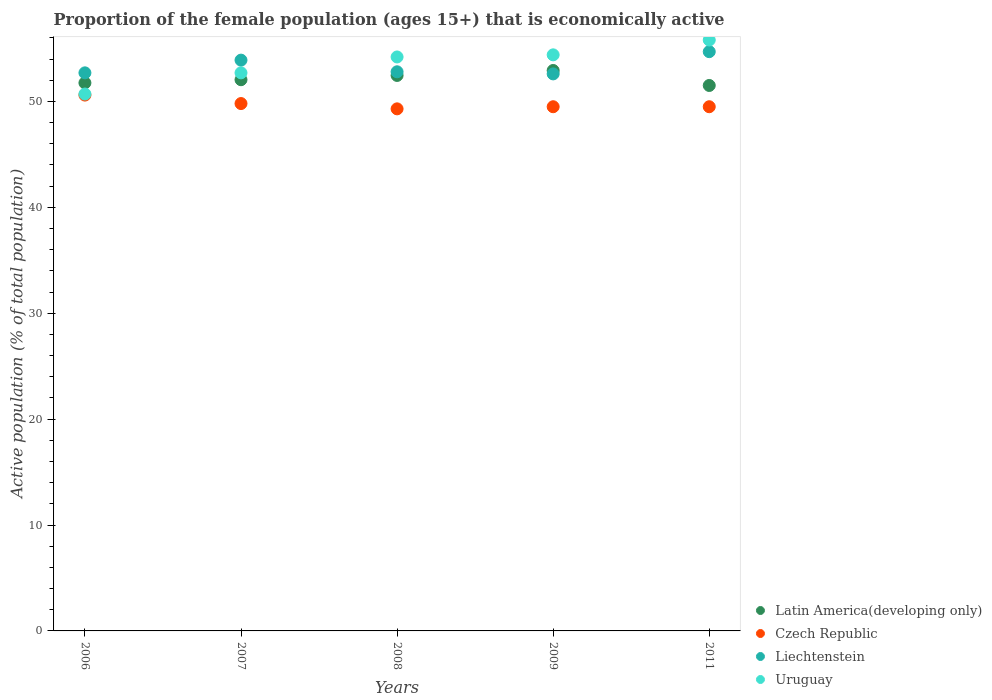How many different coloured dotlines are there?
Offer a very short reply. 4. What is the proportion of the female population that is economically active in Uruguay in 2011?
Your answer should be very brief. 55.8. Across all years, what is the maximum proportion of the female population that is economically active in Czech Republic?
Your response must be concise. 50.6. Across all years, what is the minimum proportion of the female population that is economically active in Czech Republic?
Offer a very short reply. 49.3. In which year was the proportion of the female population that is economically active in Czech Republic minimum?
Your answer should be compact. 2008. What is the total proportion of the female population that is economically active in Uruguay in the graph?
Ensure brevity in your answer.  267.8. What is the difference between the proportion of the female population that is economically active in Czech Republic in 2006 and that in 2011?
Your answer should be very brief. 1.1. What is the difference between the proportion of the female population that is economically active in Uruguay in 2006 and the proportion of the female population that is economically active in Czech Republic in 2011?
Give a very brief answer. 1.2. What is the average proportion of the female population that is economically active in Uruguay per year?
Ensure brevity in your answer.  53.56. In the year 2006, what is the difference between the proportion of the female population that is economically active in Uruguay and proportion of the female population that is economically active in Czech Republic?
Your answer should be compact. 0.1. In how many years, is the proportion of the female population that is economically active in Liechtenstein greater than 38 %?
Make the answer very short. 5. What is the ratio of the proportion of the female population that is economically active in Uruguay in 2007 to that in 2009?
Make the answer very short. 0.97. What is the difference between the highest and the second highest proportion of the female population that is economically active in Uruguay?
Your answer should be compact. 1.4. What is the difference between the highest and the lowest proportion of the female population that is economically active in Latin America(developing only)?
Your answer should be very brief. 1.41. Is it the case that in every year, the sum of the proportion of the female population that is economically active in Liechtenstein and proportion of the female population that is economically active in Latin America(developing only)  is greater than the proportion of the female population that is economically active in Czech Republic?
Keep it short and to the point. Yes. Is the proportion of the female population that is economically active in Latin America(developing only) strictly greater than the proportion of the female population that is economically active in Liechtenstein over the years?
Your answer should be compact. No. Is the proportion of the female population that is economically active in Czech Republic strictly less than the proportion of the female population that is economically active in Latin America(developing only) over the years?
Ensure brevity in your answer.  Yes. What is the difference between two consecutive major ticks on the Y-axis?
Give a very brief answer. 10. Are the values on the major ticks of Y-axis written in scientific E-notation?
Offer a terse response. No. Does the graph contain grids?
Give a very brief answer. No. How many legend labels are there?
Offer a very short reply. 4. How are the legend labels stacked?
Keep it short and to the point. Vertical. What is the title of the graph?
Give a very brief answer. Proportion of the female population (ages 15+) that is economically active. Does "Sweden" appear as one of the legend labels in the graph?
Your answer should be very brief. No. What is the label or title of the Y-axis?
Give a very brief answer. Active population (% of total population). What is the Active population (% of total population) in Latin America(developing only) in 2006?
Offer a terse response. 51.75. What is the Active population (% of total population) of Czech Republic in 2006?
Your answer should be very brief. 50.6. What is the Active population (% of total population) of Liechtenstein in 2006?
Your answer should be very brief. 52.7. What is the Active population (% of total population) in Uruguay in 2006?
Offer a very short reply. 50.7. What is the Active population (% of total population) in Latin America(developing only) in 2007?
Offer a terse response. 52.05. What is the Active population (% of total population) of Czech Republic in 2007?
Provide a short and direct response. 49.8. What is the Active population (% of total population) in Liechtenstein in 2007?
Your answer should be compact. 53.9. What is the Active population (% of total population) of Uruguay in 2007?
Provide a short and direct response. 52.7. What is the Active population (% of total population) of Latin America(developing only) in 2008?
Give a very brief answer. 52.45. What is the Active population (% of total population) of Czech Republic in 2008?
Keep it short and to the point. 49.3. What is the Active population (% of total population) in Liechtenstein in 2008?
Make the answer very short. 52.8. What is the Active population (% of total population) in Uruguay in 2008?
Provide a short and direct response. 54.2. What is the Active population (% of total population) in Latin America(developing only) in 2009?
Offer a very short reply. 52.92. What is the Active population (% of total population) in Czech Republic in 2009?
Your answer should be compact. 49.5. What is the Active population (% of total population) of Liechtenstein in 2009?
Provide a succinct answer. 52.6. What is the Active population (% of total population) in Uruguay in 2009?
Keep it short and to the point. 54.4. What is the Active population (% of total population) in Latin America(developing only) in 2011?
Ensure brevity in your answer.  51.51. What is the Active population (% of total population) of Czech Republic in 2011?
Give a very brief answer. 49.5. What is the Active population (% of total population) in Liechtenstein in 2011?
Offer a terse response. 54.7. What is the Active population (% of total population) in Uruguay in 2011?
Ensure brevity in your answer.  55.8. Across all years, what is the maximum Active population (% of total population) in Latin America(developing only)?
Your response must be concise. 52.92. Across all years, what is the maximum Active population (% of total population) in Czech Republic?
Keep it short and to the point. 50.6. Across all years, what is the maximum Active population (% of total population) of Liechtenstein?
Offer a terse response. 54.7. Across all years, what is the maximum Active population (% of total population) in Uruguay?
Make the answer very short. 55.8. Across all years, what is the minimum Active population (% of total population) in Latin America(developing only)?
Offer a terse response. 51.51. Across all years, what is the minimum Active population (% of total population) of Czech Republic?
Keep it short and to the point. 49.3. Across all years, what is the minimum Active population (% of total population) in Liechtenstein?
Your answer should be compact. 52.6. Across all years, what is the minimum Active population (% of total population) of Uruguay?
Your answer should be very brief. 50.7. What is the total Active population (% of total population) of Latin America(developing only) in the graph?
Your answer should be very brief. 260.69. What is the total Active population (% of total population) in Czech Republic in the graph?
Keep it short and to the point. 248.7. What is the total Active population (% of total population) of Liechtenstein in the graph?
Offer a terse response. 266.7. What is the total Active population (% of total population) of Uruguay in the graph?
Ensure brevity in your answer.  267.8. What is the difference between the Active population (% of total population) of Czech Republic in 2006 and that in 2007?
Keep it short and to the point. 0.8. What is the difference between the Active population (% of total population) of Liechtenstein in 2006 and that in 2007?
Offer a very short reply. -1.2. What is the difference between the Active population (% of total population) in Latin America(developing only) in 2006 and that in 2008?
Keep it short and to the point. -0.7. What is the difference between the Active population (% of total population) of Czech Republic in 2006 and that in 2008?
Offer a terse response. 1.3. What is the difference between the Active population (% of total population) of Latin America(developing only) in 2006 and that in 2009?
Your response must be concise. -1.17. What is the difference between the Active population (% of total population) in Czech Republic in 2006 and that in 2009?
Offer a terse response. 1.1. What is the difference between the Active population (% of total population) in Liechtenstein in 2006 and that in 2009?
Your response must be concise. 0.1. What is the difference between the Active population (% of total population) of Latin America(developing only) in 2006 and that in 2011?
Offer a terse response. 0.24. What is the difference between the Active population (% of total population) of Uruguay in 2006 and that in 2011?
Offer a terse response. -5.1. What is the difference between the Active population (% of total population) of Latin America(developing only) in 2007 and that in 2008?
Ensure brevity in your answer.  -0.4. What is the difference between the Active population (% of total population) in Liechtenstein in 2007 and that in 2008?
Your response must be concise. 1.1. What is the difference between the Active population (% of total population) of Uruguay in 2007 and that in 2008?
Make the answer very short. -1.5. What is the difference between the Active population (% of total population) in Latin America(developing only) in 2007 and that in 2009?
Provide a succinct answer. -0.87. What is the difference between the Active population (% of total population) of Czech Republic in 2007 and that in 2009?
Your answer should be compact. 0.3. What is the difference between the Active population (% of total population) in Uruguay in 2007 and that in 2009?
Keep it short and to the point. -1.7. What is the difference between the Active population (% of total population) in Latin America(developing only) in 2007 and that in 2011?
Offer a terse response. 0.54. What is the difference between the Active population (% of total population) in Liechtenstein in 2007 and that in 2011?
Provide a succinct answer. -0.8. What is the difference between the Active population (% of total population) in Latin America(developing only) in 2008 and that in 2009?
Provide a short and direct response. -0.47. What is the difference between the Active population (% of total population) in Czech Republic in 2008 and that in 2009?
Provide a succinct answer. -0.2. What is the difference between the Active population (% of total population) in Liechtenstein in 2008 and that in 2009?
Give a very brief answer. 0.2. What is the difference between the Active population (% of total population) in Latin America(developing only) in 2008 and that in 2011?
Your answer should be very brief. 0.95. What is the difference between the Active population (% of total population) of Czech Republic in 2008 and that in 2011?
Give a very brief answer. -0.2. What is the difference between the Active population (% of total population) of Latin America(developing only) in 2009 and that in 2011?
Offer a very short reply. 1.41. What is the difference between the Active population (% of total population) in Czech Republic in 2009 and that in 2011?
Provide a succinct answer. 0. What is the difference between the Active population (% of total population) of Liechtenstein in 2009 and that in 2011?
Keep it short and to the point. -2.1. What is the difference between the Active population (% of total population) in Latin America(developing only) in 2006 and the Active population (% of total population) in Czech Republic in 2007?
Keep it short and to the point. 1.95. What is the difference between the Active population (% of total population) in Latin America(developing only) in 2006 and the Active population (% of total population) in Liechtenstein in 2007?
Provide a succinct answer. -2.15. What is the difference between the Active population (% of total population) in Latin America(developing only) in 2006 and the Active population (% of total population) in Uruguay in 2007?
Your response must be concise. -0.95. What is the difference between the Active population (% of total population) in Czech Republic in 2006 and the Active population (% of total population) in Liechtenstein in 2007?
Provide a succinct answer. -3.3. What is the difference between the Active population (% of total population) of Czech Republic in 2006 and the Active population (% of total population) of Uruguay in 2007?
Your response must be concise. -2.1. What is the difference between the Active population (% of total population) in Liechtenstein in 2006 and the Active population (% of total population) in Uruguay in 2007?
Offer a terse response. 0. What is the difference between the Active population (% of total population) in Latin America(developing only) in 2006 and the Active population (% of total population) in Czech Republic in 2008?
Give a very brief answer. 2.45. What is the difference between the Active population (% of total population) in Latin America(developing only) in 2006 and the Active population (% of total population) in Liechtenstein in 2008?
Make the answer very short. -1.05. What is the difference between the Active population (% of total population) of Latin America(developing only) in 2006 and the Active population (% of total population) of Uruguay in 2008?
Provide a succinct answer. -2.45. What is the difference between the Active population (% of total population) of Czech Republic in 2006 and the Active population (% of total population) of Uruguay in 2008?
Offer a very short reply. -3.6. What is the difference between the Active population (% of total population) in Liechtenstein in 2006 and the Active population (% of total population) in Uruguay in 2008?
Make the answer very short. -1.5. What is the difference between the Active population (% of total population) of Latin America(developing only) in 2006 and the Active population (% of total population) of Czech Republic in 2009?
Ensure brevity in your answer.  2.25. What is the difference between the Active population (% of total population) of Latin America(developing only) in 2006 and the Active population (% of total population) of Liechtenstein in 2009?
Provide a short and direct response. -0.85. What is the difference between the Active population (% of total population) in Latin America(developing only) in 2006 and the Active population (% of total population) in Uruguay in 2009?
Provide a short and direct response. -2.65. What is the difference between the Active population (% of total population) of Czech Republic in 2006 and the Active population (% of total population) of Liechtenstein in 2009?
Your answer should be compact. -2. What is the difference between the Active population (% of total population) in Czech Republic in 2006 and the Active population (% of total population) in Uruguay in 2009?
Give a very brief answer. -3.8. What is the difference between the Active population (% of total population) of Latin America(developing only) in 2006 and the Active population (% of total population) of Czech Republic in 2011?
Your response must be concise. 2.25. What is the difference between the Active population (% of total population) of Latin America(developing only) in 2006 and the Active population (% of total population) of Liechtenstein in 2011?
Offer a very short reply. -2.95. What is the difference between the Active population (% of total population) in Latin America(developing only) in 2006 and the Active population (% of total population) in Uruguay in 2011?
Provide a short and direct response. -4.05. What is the difference between the Active population (% of total population) of Latin America(developing only) in 2007 and the Active population (% of total population) of Czech Republic in 2008?
Keep it short and to the point. 2.75. What is the difference between the Active population (% of total population) of Latin America(developing only) in 2007 and the Active population (% of total population) of Liechtenstein in 2008?
Provide a succinct answer. -0.75. What is the difference between the Active population (% of total population) of Latin America(developing only) in 2007 and the Active population (% of total population) of Uruguay in 2008?
Provide a succinct answer. -2.15. What is the difference between the Active population (% of total population) of Latin America(developing only) in 2007 and the Active population (% of total population) of Czech Republic in 2009?
Make the answer very short. 2.55. What is the difference between the Active population (% of total population) of Latin America(developing only) in 2007 and the Active population (% of total population) of Liechtenstein in 2009?
Provide a succinct answer. -0.55. What is the difference between the Active population (% of total population) of Latin America(developing only) in 2007 and the Active population (% of total population) of Uruguay in 2009?
Your answer should be compact. -2.35. What is the difference between the Active population (% of total population) of Czech Republic in 2007 and the Active population (% of total population) of Uruguay in 2009?
Make the answer very short. -4.6. What is the difference between the Active population (% of total population) of Latin America(developing only) in 2007 and the Active population (% of total population) of Czech Republic in 2011?
Provide a short and direct response. 2.55. What is the difference between the Active population (% of total population) in Latin America(developing only) in 2007 and the Active population (% of total population) in Liechtenstein in 2011?
Your answer should be very brief. -2.65. What is the difference between the Active population (% of total population) in Latin America(developing only) in 2007 and the Active population (% of total population) in Uruguay in 2011?
Make the answer very short. -3.75. What is the difference between the Active population (% of total population) of Czech Republic in 2007 and the Active population (% of total population) of Liechtenstein in 2011?
Give a very brief answer. -4.9. What is the difference between the Active population (% of total population) in Liechtenstein in 2007 and the Active population (% of total population) in Uruguay in 2011?
Your response must be concise. -1.9. What is the difference between the Active population (% of total population) in Latin America(developing only) in 2008 and the Active population (% of total population) in Czech Republic in 2009?
Your response must be concise. 2.95. What is the difference between the Active population (% of total population) in Latin America(developing only) in 2008 and the Active population (% of total population) in Liechtenstein in 2009?
Provide a succinct answer. -0.15. What is the difference between the Active population (% of total population) in Latin America(developing only) in 2008 and the Active population (% of total population) in Uruguay in 2009?
Your answer should be compact. -1.95. What is the difference between the Active population (% of total population) in Czech Republic in 2008 and the Active population (% of total population) in Liechtenstein in 2009?
Provide a short and direct response. -3.3. What is the difference between the Active population (% of total population) in Czech Republic in 2008 and the Active population (% of total population) in Uruguay in 2009?
Ensure brevity in your answer.  -5.1. What is the difference between the Active population (% of total population) in Latin America(developing only) in 2008 and the Active population (% of total population) in Czech Republic in 2011?
Give a very brief answer. 2.95. What is the difference between the Active population (% of total population) in Latin America(developing only) in 2008 and the Active population (% of total population) in Liechtenstein in 2011?
Ensure brevity in your answer.  -2.25. What is the difference between the Active population (% of total population) of Latin America(developing only) in 2008 and the Active population (% of total population) of Uruguay in 2011?
Your response must be concise. -3.35. What is the difference between the Active population (% of total population) of Czech Republic in 2008 and the Active population (% of total population) of Liechtenstein in 2011?
Make the answer very short. -5.4. What is the difference between the Active population (% of total population) of Czech Republic in 2008 and the Active population (% of total population) of Uruguay in 2011?
Your response must be concise. -6.5. What is the difference between the Active population (% of total population) of Liechtenstein in 2008 and the Active population (% of total population) of Uruguay in 2011?
Keep it short and to the point. -3. What is the difference between the Active population (% of total population) of Latin America(developing only) in 2009 and the Active population (% of total population) of Czech Republic in 2011?
Provide a short and direct response. 3.42. What is the difference between the Active population (% of total population) in Latin America(developing only) in 2009 and the Active population (% of total population) in Liechtenstein in 2011?
Ensure brevity in your answer.  -1.78. What is the difference between the Active population (% of total population) of Latin America(developing only) in 2009 and the Active population (% of total population) of Uruguay in 2011?
Ensure brevity in your answer.  -2.88. What is the difference between the Active population (% of total population) in Czech Republic in 2009 and the Active population (% of total population) in Uruguay in 2011?
Keep it short and to the point. -6.3. What is the average Active population (% of total population) of Latin America(developing only) per year?
Keep it short and to the point. 52.14. What is the average Active population (% of total population) in Czech Republic per year?
Ensure brevity in your answer.  49.74. What is the average Active population (% of total population) in Liechtenstein per year?
Your answer should be very brief. 53.34. What is the average Active population (% of total population) of Uruguay per year?
Ensure brevity in your answer.  53.56. In the year 2006, what is the difference between the Active population (% of total population) of Latin America(developing only) and Active population (% of total population) of Czech Republic?
Give a very brief answer. 1.15. In the year 2006, what is the difference between the Active population (% of total population) of Latin America(developing only) and Active population (% of total population) of Liechtenstein?
Keep it short and to the point. -0.95. In the year 2006, what is the difference between the Active population (% of total population) in Latin America(developing only) and Active population (% of total population) in Uruguay?
Provide a short and direct response. 1.05. In the year 2006, what is the difference between the Active population (% of total population) in Czech Republic and Active population (% of total population) in Liechtenstein?
Your answer should be compact. -2.1. In the year 2006, what is the difference between the Active population (% of total population) in Liechtenstein and Active population (% of total population) in Uruguay?
Your answer should be compact. 2. In the year 2007, what is the difference between the Active population (% of total population) of Latin America(developing only) and Active population (% of total population) of Czech Republic?
Make the answer very short. 2.25. In the year 2007, what is the difference between the Active population (% of total population) of Latin America(developing only) and Active population (% of total population) of Liechtenstein?
Keep it short and to the point. -1.85. In the year 2007, what is the difference between the Active population (% of total population) in Latin America(developing only) and Active population (% of total population) in Uruguay?
Your answer should be very brief. -0.65. In the year 2007, what is the difference between the Active population (% of total population) in Czech Republic and Active population (% of total population) in Liechtenstein?
Keep it short and to the point. -4.1. In the year 2007, what is the difference between the Active population (% of total population) in Czech Republic and Active population (% of total population) in Uruguay?
Keep it short and to the point. -2.9. In the year 2008, what is the difference between the Active population (% of total population) in Latin America(developing only) and Active population (% of total population) in Czech Republic?
Make the answer very short. 3.15. In the year 2008, what is the difference between the Active population (% of total population) in Latin America(developing only) and Active population (% of total population) in Liechtenstein?
Offer a very short reply. -0.35. In the year 2008, what is the difference between the Active population (% of total population) of Latin America(developing only) and Active population (% of total population) of Uruguay?
Your answer should be very brief. -1.75. In the year 2008, what is the difference between the Active population (% of total population) of Czech Republic and Active population (% of total population) of Liechtenstein?
Give a very brief answer. -3.5. In the year 2008, what is the difference between the Active population (% of total population) of Czech Republic and Active population (% of total population) of Uruguay?
Your answer should be compact. -4.9. In the year 2009, what is the difference between the Active population (% of total population) of Latin America(developing only) and Active population (% of total population) of Czech Republic?
Provide a succinct answer. 3.42. In the year 2009, what is the difference between the Active population (% of total population) in Latin America(developing only) and Active population (% of total population) in Liechtenstein?
Provide a short and direct response. 0.32. In the year 2009, what is the difference between the Active population (% of total population) in Latin America(developing only) and Active population (% of total population) in Uruguay?
Provide a short and direct response. -1.48. In the year 2009, what is the difference between the Active population (% of total population) of Czech Republic and Active population (% of total population) of Liechtenstein?
Your answer should be compact. -3.1. In the year 2009, what is the difference between the Active population (% of total population) of Liechtenstein and Active population (% of total population) of Uruguay?
Offer a very short reply. -1.8. In the year 2011, what is the difference between the Active population (% of total population) of Latin America(developing only) and Active population (% of total population) of Czech Republic?
Ensure brevity in your answer.  2.01. In the year 2011, what is the difference between the Active population (% of total population) in Latin America(developing only) and Active population (% of total population) in Liechtenstein?
Give a very brief answer. -3.19. In the year 2011, what is the difference between the Active population (% of total population) in Latin America(developing only) and Active population (% of total population) in Uruguay?
Ensure brevity in your answer.  -4.29. In the year 2011, what is the difference between the Active population (% of total population) of Liechtenstein and Active population (% of total population) of Uruguay?
Provide a short and direct response. -1.1. What is the ratio of the Active population (% of total population) of Latin America(developing only) in 2006 to that in 2007?
Make the answer very short. 0.99. What is the ratio of the Active population (% of total population) in Czech Republic in 2006 to that in 2007?
Keep it short and to the point. 1.02. What is the ratio of the Active population (% of total population) of Liechtenstein in 2006 to that in 2007?
Give a very brief answer. 0.98. What is the ratio of the Active population (% of total population) in Uruguay in 2006 to that in 2007?
Provide a short and direct response. 0.96. What is the ratio of the Active population (% of total population) in Latin America(developing only) in 2006 to that in 2008?
Offer a very short reply. 0.99. What is the ratio of the Active population (% of total population) in Czech Republic in 2006 to that in 2008?
Offer a terse response. 1.03. What is the ratio of the Active population (% of total population) in Liechtenstein in 2006 to that in 2008?
Your answer should be very brief. 1. What is the ratio of the Active population (% of total population) in Uruguay in 2006 to that in 2008?
Ensure brevity in your answer.  0.94. What is the ratio of the Active population (% of total population) in Latin America(developing only) in 2006 to that in 2009?
Ensure brevity in your answer.  0.98. What is the ratio of the Active population (% of total population) in Czech Republic in 2006 to that in 2009?
Make the answer very short. 1.02. What is the ratio of the Active population (% of total population) of Uruguay in 2006 to that in 2009?
Offer a terse response. 0.93. What is the ratio of the Active population (% of total population) of Czech Republic in 2006 to that in 2011?
Give a very brief answer. 1.02. What is the ratio of the Active population (% of total population) in Liechtenstein in 2006 to that in 2011?
Your answer should be compact. 0.96. What is the ratio of the Active population (% of total population) in Uruguay in 2006 to that in 2011?
Ensure brevity in your answer.  0.91. What is the ratio of the Active population (% of total population) of Czech Republic in 2007 to that in 2008?
Your response must be concise. 1.01. What is the ratio of the Active population (% of total population) of Liechtenstein in 2007 to that in 2008?
Make the answer very short. 1.02. What is the ratio of the Active population (% of total population) in Uruguay in 2007 to that in 2008?
Your answer should be very brief. 0.97. What is the ratio of the Active population (% of total population) in Latin America(developing only) in 2007 to that in 2009?
Provide a short and direct response. 0.98. What is the ratio of the Active population (% of total population) of Czech Republic in 2007 to that in 2009?
Keep it short and to the point. 1.01. What is the ratio of the Active population (% of total population) in Liechtenstein in 2007 to that in 2009?
Ensure brevity in your answer.  1.02. What is the ratio of the Active population (% of total population) in Uruguay in 2007 to that in 2009?
Your response must be concise. 0.97. What is the ratio of the Active population (% of total population) in Latin America(developing only) in 2007 to that in 2011?
Offer a very short reply. 1.01. What is the ratio of the Active population (% of total population) in Liechtenstein in 2007 to that in 2011?
Your response must be concise. 0.99. What is the ratio of the Active population (% of total population) in Latin America(developing only) in 2008 to that in 2009?
Ensure brevity in your answer.  0.99. What is the ratio of the Active population (% of total population) in Czech Republic in 2008 to that in 2009?
Keep it short and to the point. 1. What is the ratio of the Active population (% of total population) of Uruguay in 2008 to that in 2009?
Your response must be concise. 1. What is the ratio of the Active population (% of total population) of Latin America(developing only) in 2008 to that in 2011?
Your response must be concise. 1.02. What is the ratio of the Active population (% of total population) in Liechtenstein in 2008 to that in 2011?
Ensure brevity in your answer.  0.97. What is the ratio of the Active population (% of total population) in Uruguay in 2008 to that in 2011?
Offer a very short reply. 0.97. What is the ratio of the Active population (% of total population) of Latin America(developing only) in 2009 to that in 2011?
Make the answer very short. 1.03. What is the ratio of the Active population (% of total population) in Czech Republic in 2009 to that in 2011?
Give a very brief answer. 1. What is the ratio of the Active population (% of total population) of Liechtenstein in 2009 to that in 2011?
Make the answer very short. 0.96. What is the ratio of the Active population (% of total population) in Uruguay in 2009 to that in 2011?
Your response must be concise. 0.97. What is the difference between the highest and the second highest Active population (% of total population) in Latin America(developing only)?
Your answer should be compact. 0.47. What is the difference between the highest and the second highest Active population (% of total population) in Czech Republic?
Offer a terse response. 0.8. What is the difference between the highest and the second highest Active population (% of total population) of Liechtenstein?
Your response must be concise. 0.8. What is the difference between the highest and the lowest Active population (% of total population) in Latin America(developing only)?
Give a very brief answer. 1.41. 